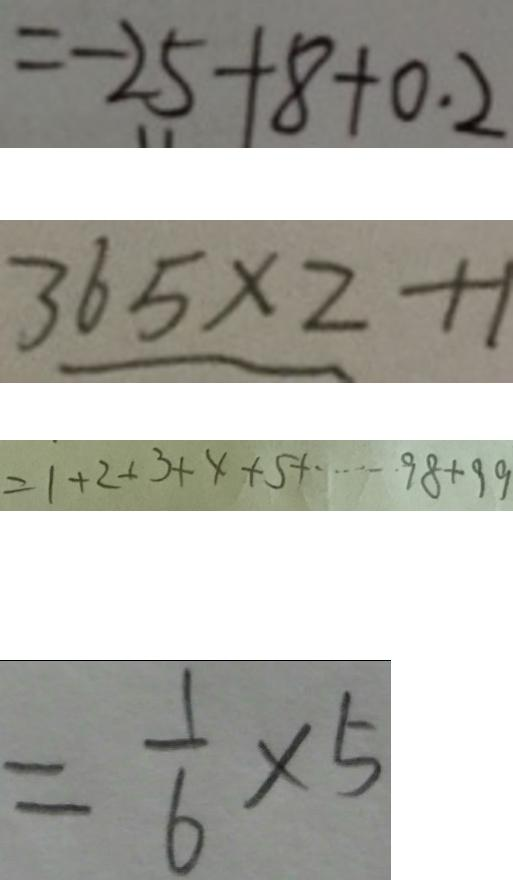<formula> <loc_0><loc_0><loc_500><loc_500>= - 2 5 + 8 + 0 . 2 
 3 6 5 \times 2 + 1 
 = 1 + 2 + 3 + 4 + 5 + \cdots 9 8 + 9 9 
 = \frac { 1 } { 6 } \times 5</formula> 